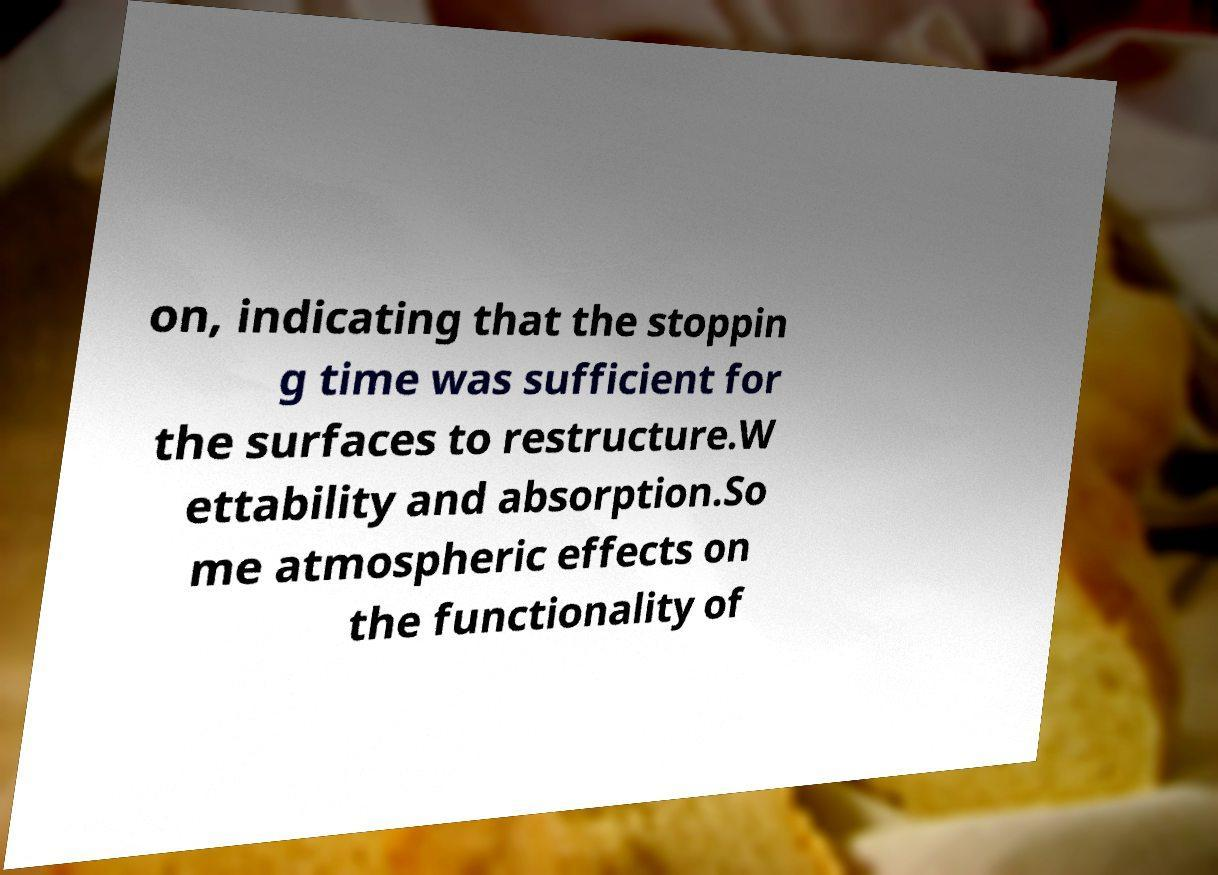Could you extract and type out the text from this image? on, indicating that the stoppin g time was sufficient for the surfaces to restructure.W ettability and absorption.So me atmospheric effects on the functionality of 